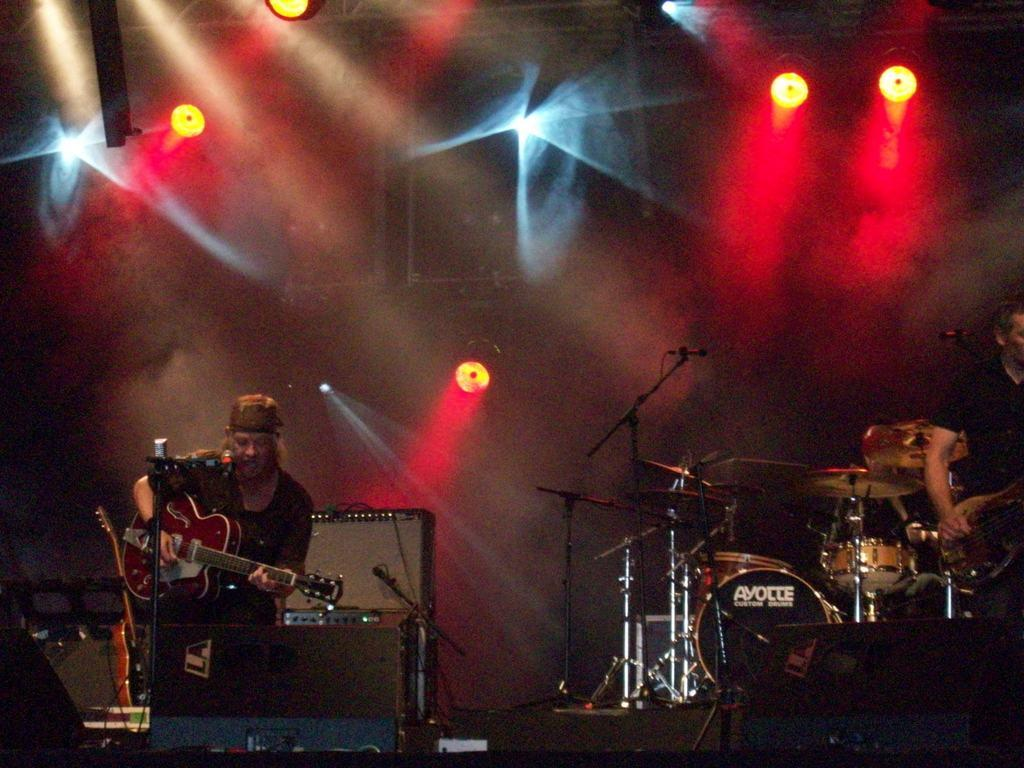What is the person in the image doing? The person is sitting and holding a guitar, and they are playing the guitar. What other musical instrument can be seen in the image? There is a drum in the image. What equipment is present for amplifying sound? There is a mic stand in the image. What can be seen in the background of the image? There are lights and other equipment on the stage in the background of the image. What type of polish is the person applying to the guitar in the image? There is no indication in the image that the person is applying any polish to the guitar. How many boys are visible in the image? The image does not show any boys; it features a person playing a guitar and other musical equipment. 